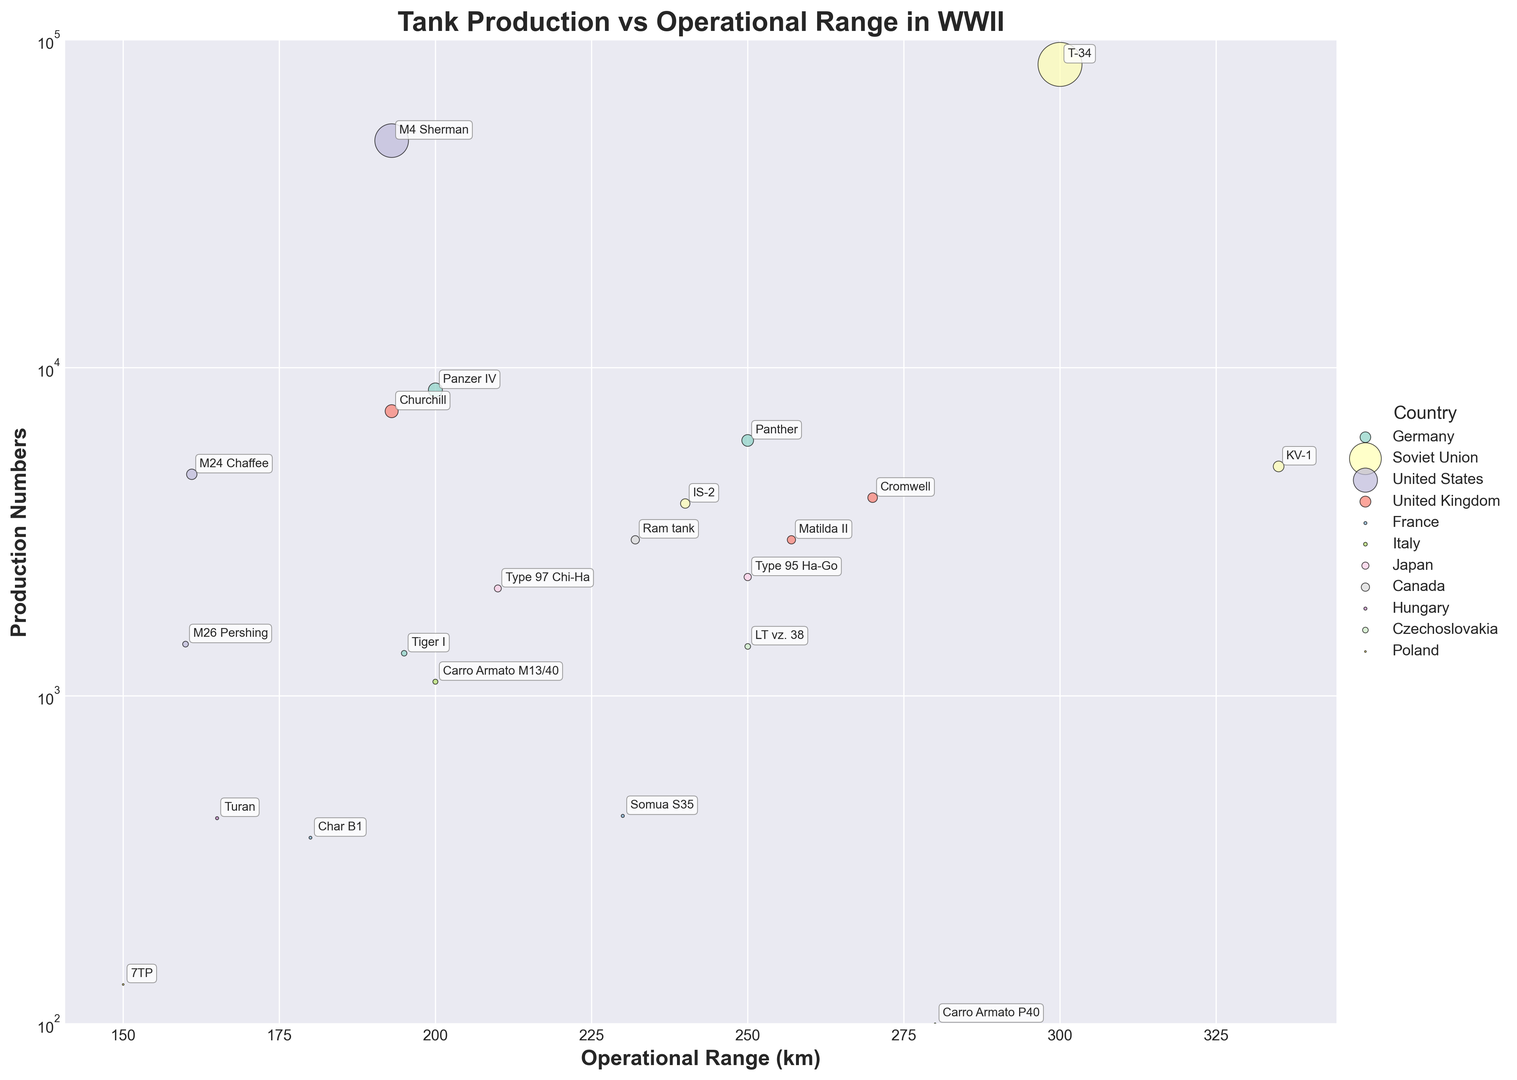Which nation has the tank model with the highest operational range? The tank model with the highest operational range can be identified by finding the highest point on the x-axis (Operational Range) and then determining the corresponding nation. The KV-1 from the Soviet Union has the highest operational range at 335 km.
Answer: Soviet Union Which tank models from the United States have an operational range below 200 km? By scanning the scatter plot, we look for tank models labeled under the United States with x-axis values less than 200 km. The M26 Pershing and M24 Chaffee fit this criterion with operational ranges of 160 km and 161 km respectively.
Answer: M26 Pershing, M24 Chaffee Comparing Germany and the Soviet Union, which nation has the higher production numbers for their most produced tank model? We locate the highest production number (y-axis) for each nation and compare them. The Panzer IV of Germany has 8,553 units, whereas the T-34 of the Soviet Union has 84,070 units. The Soviet Union has higher production numbers for its T-34.
Answer: Soviet Union What is the combined production number of all French tank models? We sum the production numbers of each French tank model: Char B1 (369) and Somua S35 (430). The total is 369 + 430 = 799.
Answer: 799 Does any tank model from Japan have a higher operational range than any tank model from the UK? We compare the operational ranges of Japanese tank models with those of the UK. The highest operational range of Japanese models is 250 km (Type 97 Chi-Ha and Type 95 Ha-Go), and for the UK it is 270 km (Cromwell). No Japanese model has a higher operational range than any UK model.
Answer: No Which tank model has the smallest production number among all nations, and what is its operational range? By identifying the smallest point on the y-axis and checking the label, the Carro Armato P40 from Italy has the smallest production number (100 units) with an operational range of 280 km.
Answer: Carro Armato P40, 280 km How many tank models have an operational range equal to or greater than 250 km? By scanning the x-axis, tank models with an operational range of at least 250 km are identified: Panther (250 km), Matilda II (257 km), Carro Armato P40 (280 km), and KV-1 (335 km). There are 4 such models.
Answer: 4 Which nation has more tank models with operational ranges above 200 km: Germany or the United Kingdom? By counting the number of tank models with operational ranges above 200 km, Germany has Panther (250 km) and the United Kingdom has Matilda II (257 km) and Cromwell (270 km). The UK has more tank models above 200 km.
Answer: United Kingdom Which tank has both high production numbers and high operational range, based on the scatter plot? A tank with high values on both axes would need to have substantial values on both the x-axis (Operational Range) and y-axis (Production Numbers). The T-34 from the Soviet Union stands out with 84,070 production numbers and an operational range of 300 km.
Answer: T-34 